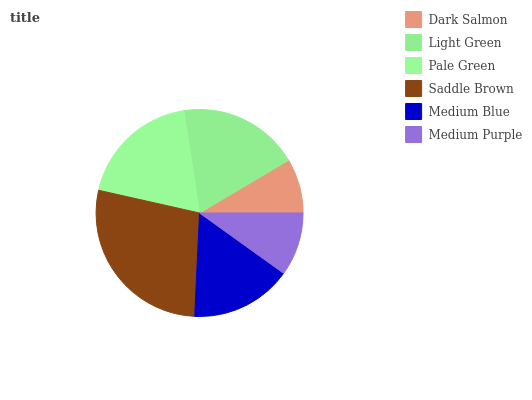Is Dark Salmon the minimum?
Answer yes or no. Yes. Is Saddle Brown the maximum?
Answer yes or no. Yes. Is Light Green the minimum?
Answer yes or no. No. Is Light Green the maximum?
Answer yes or no. No. Is Light Green greater than Dark Salmon?
Answer yes or no. Yes. Is Dark Salmon less than Light Green?
Answer yes or no. Yes. Is Dark Salmon greater than Light Green?
Answer yes or no. No. Is Light Green less than Dark Salmon?
Answer yes or no. No. Is Light Green the high median?
Answer yes or no. Yes. Is Medium Blue the low median?
Answer yes or no. Yes. Is Medium Blue the high median?
Answer yes or no. No. Is Saddle Brown the low median?
Answer yes or no. No. 